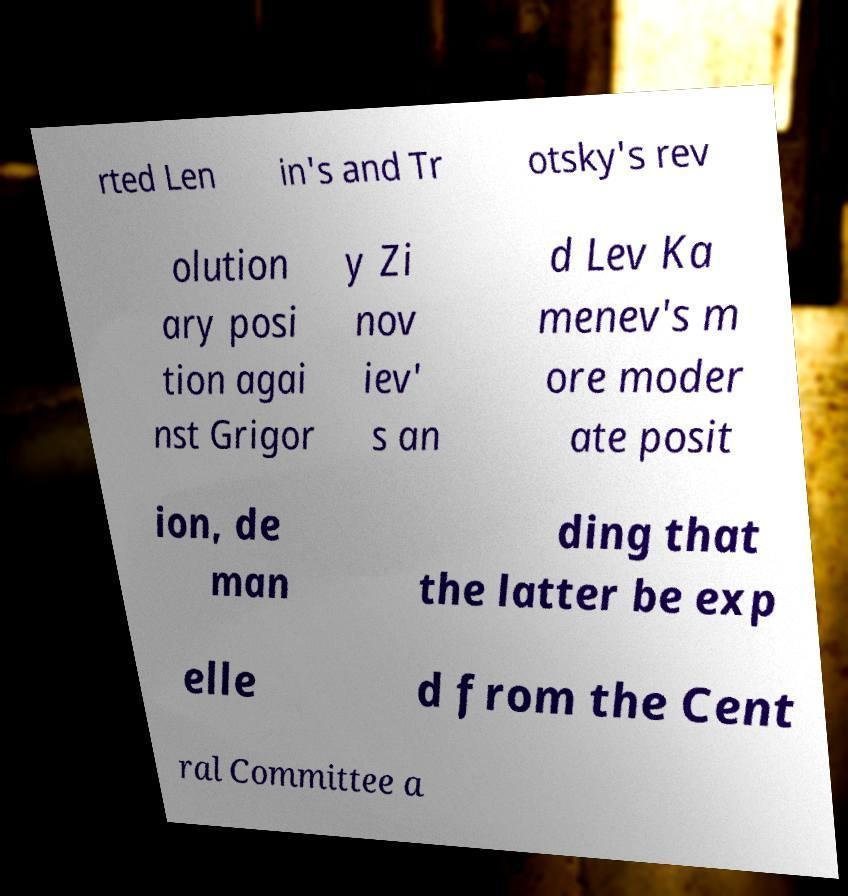For documentation purposes, I need the text within this image transcribed. Could you provide that? rted Len in's and Tr otsky's rev olution ary posi tion agai nst Grigor y Zi nov iev' s an d Lev Ka menev's m ore moder ate posit ion, de man ding that the latter be exp elle d from the Cent ral Committee a 